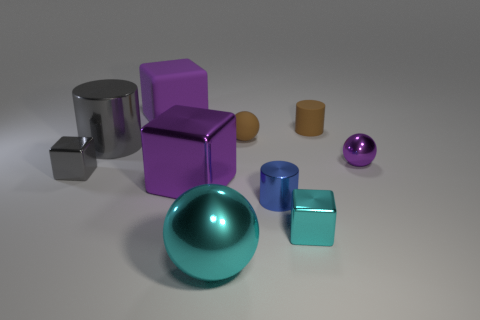Subtract all yellow spheres. How many purple cubes are left? 2 Subtract all metallic cylinders. How many cylinders are left? 1 Subtract 1 blocks. How many blocks are left? 3 Subtract all gray cubes. How many cubes are left? 3 Subtract all red balls. Subtract all cyan cylinders. How many balls are left? 3 Subtract all cubes. How many objects are left? 6 Add 4 large red matte spheres. How many large red matte spheres exist? 4 Subtract 1 purple balls. How many objects are left? 9 Subtract all tiny blue cylinders. Subtract all gray cylinders. How many objects are left? 8 Add 3 blue shiny things. How many blue shiny things are left? 4 